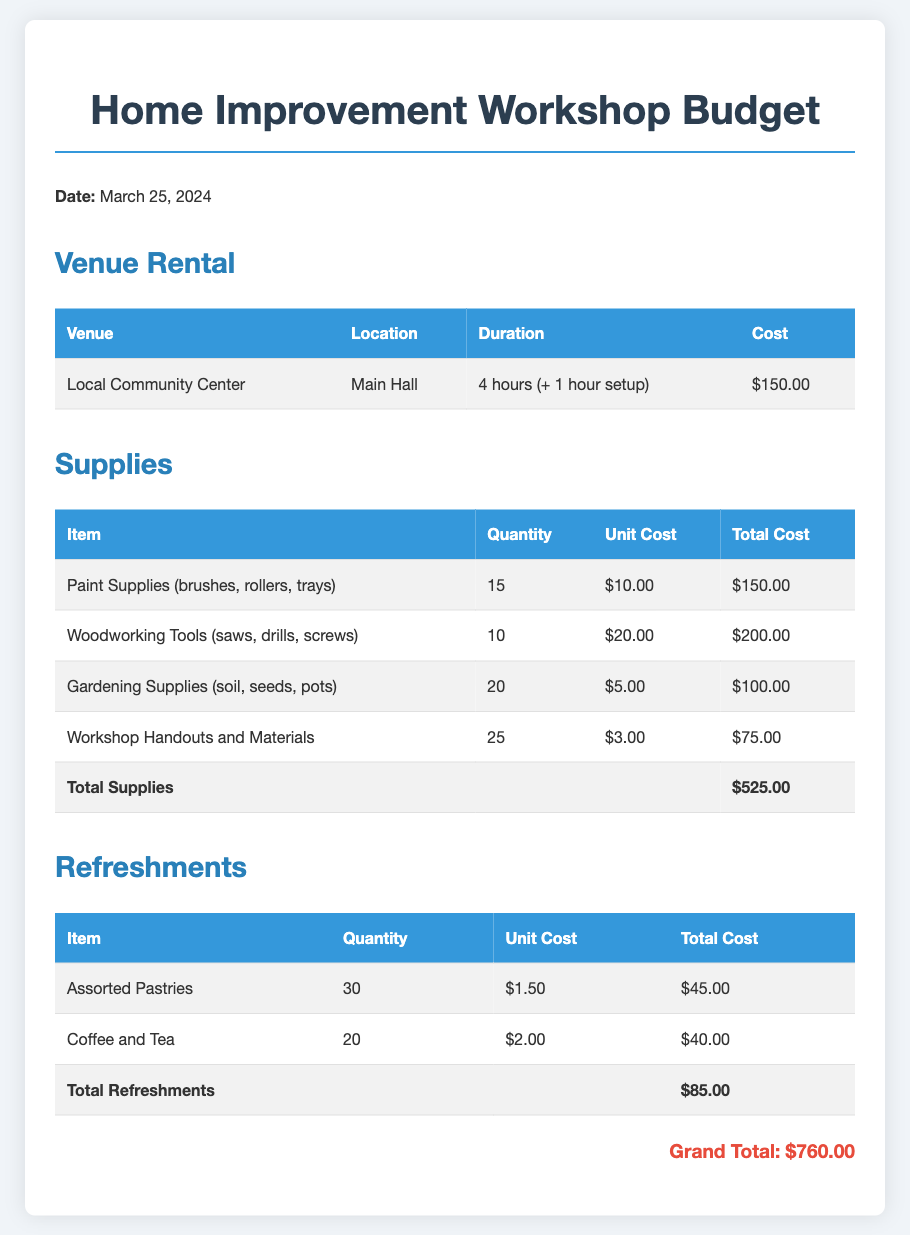What is the venue for the workshop? The venue is specified in the Venue Rental section as the Local Community Center.
Answer: Local Community Center What is the total cost of venue rental? The total cost of venue rental is listed in the Venue Rental table.
Answer: $150.00 How many types of supplies are listed? The Supplies section includes four different types of items: Paint Supplies, Woodworking Tools, Gardening Supplies, and Workshop Handouts.
Answer: 4 What is the total cost for refreshments? The total cost for refreshments can be found in the Refreshments table at the bottom.
Answer: $85.00 What is the grand total for the workshop budget? The grand total is summarized at the end of the document, combining all costs listed.
Answer: $760.00 How many assorted pastries are planned for the event? The quantity of assorted pastries is specified in the Refreshments table.
Answer: 30 What is the unit cost of gardening supplies? The unit cost for gardening supplies is indicated in the Supplies table.
Answer: $5.00 What is the item with the highest total cost in supplies? The item with the highest total cost is found by comparing the total costs of each item in the Supplies section.
Answer: Woodworking Tools How long is the workshop duration including setup? The duration is mentioned in the Venue Rental section, detailing both the workshop and setup times.
Answer: 5 hours 